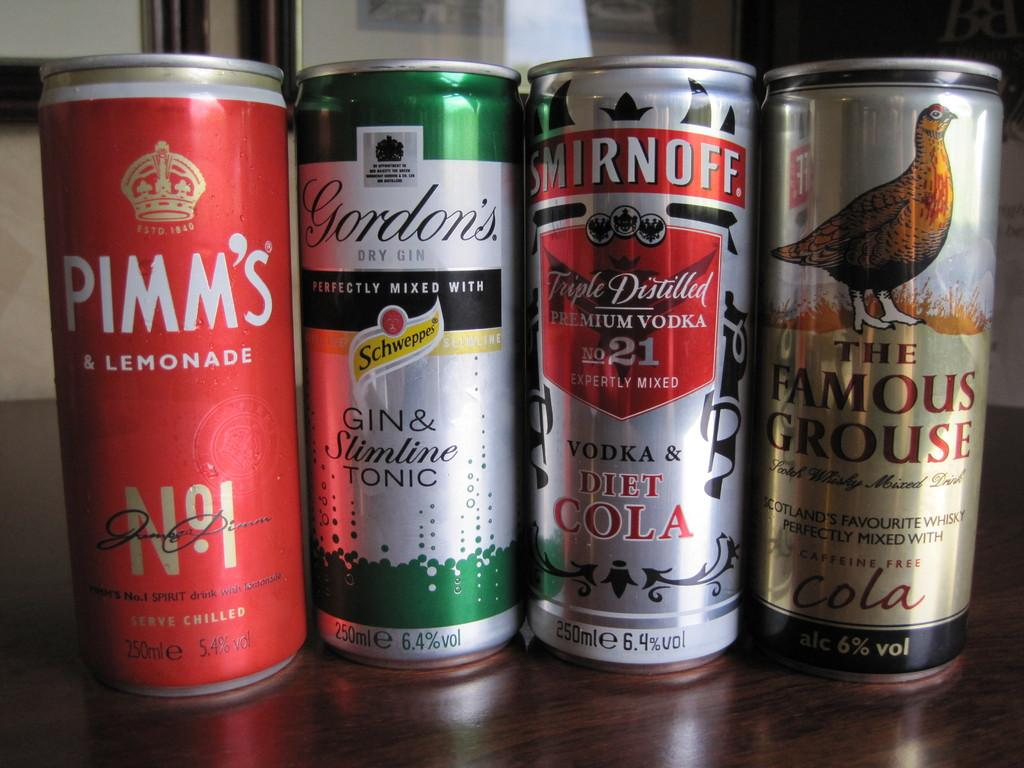What is present on the platform in the image? There are four things on a platform in the image. What is depicted on each of these things? Each thing has a picture of a bird. What additional information is provided on each of these things? Something is written on each thing. How many chickens are present on the platform in the image? There are no chickens present on the platform in the image; each thing has a picture of a bird, but the specific type of bird is not mentioned. Are there any geese depicted on the platform in the image? There is no mention of geese in the image; each thing has a picture of a bird, but the specific type of bird is not specified. 